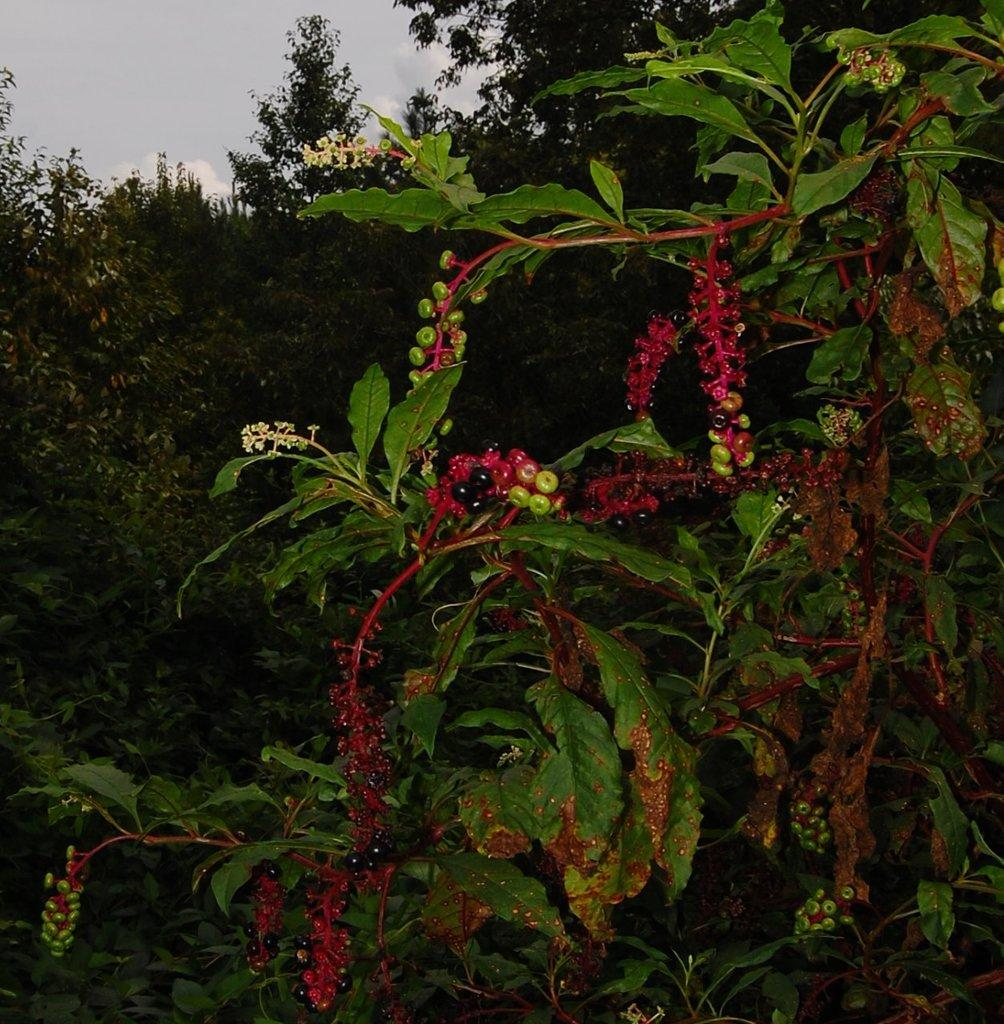What type of vegetation can be seen in the image? There are trees and flowers in the image. Can you describe the colors of the flowers? The colors of the flowers cannot be determined from the provided facts. Are there any other objects or structures visible in the image? No additional information about other objects or structures is provided in the facts. How does the plant show respect to the paper in the image? There is no paper or indication of respect present in the image; it only features trees and flowers. 